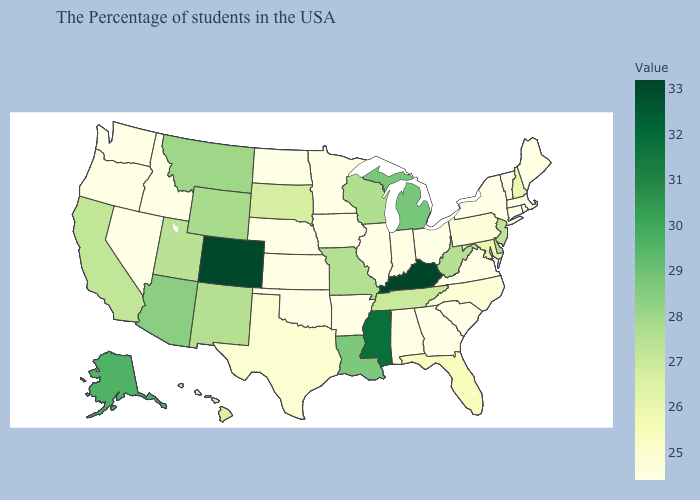Which states hav the highest value in the MidWest?
Answer briefly. Michigan. Which states have the lowest value in the USA?
Keep it brief. Maine, Massachusetts, Rhode Island, Vermont, Connecticut, New York, Virginia, South Carolina, Ohio, Georgia, Alabama, Illinois, Arkansas, Minnesota, Iowa, Kansas, Nebraska, Oklahoma, North Dakota, Idaho, Nevada, Washington, Oregon. Among the states that border South Dakota , which have the lowest value?
Write a very short answer. Minnesota, Iowa, Nebraska, North Dakota. Among the states that border Pennsylvania , which have the lowest value?
Be succinct. New York, Ohio. Does Rhode Island have the highest value in the USA?
Answer briefly. No. 